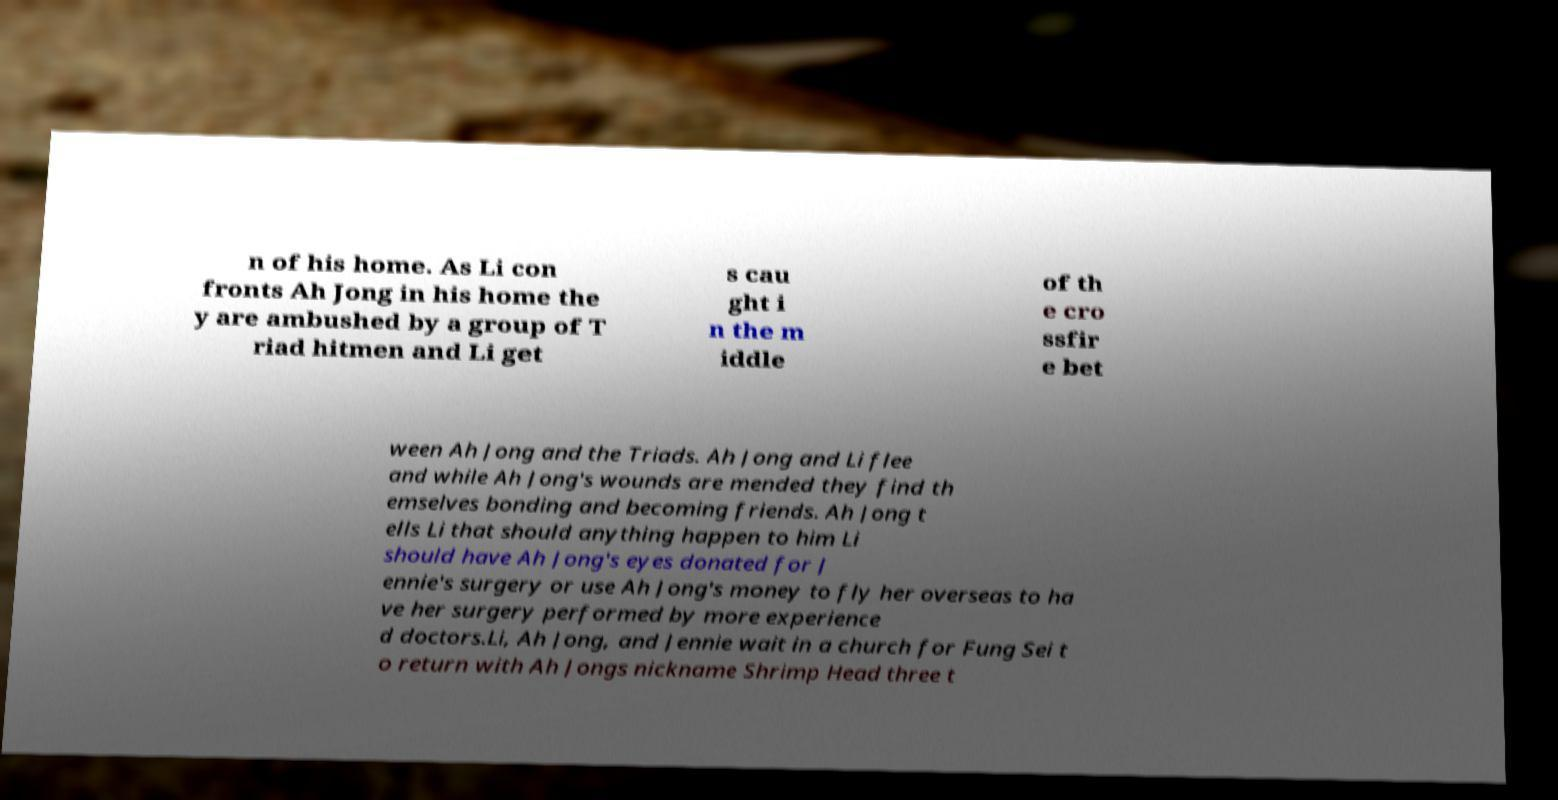For documentation purposes, I need the text within this image transcribed. Could you provide that? n of his home. As Li con fronts Ah Jong in his home the y are ambushed by a group of T riad hitmen and Li get s cau ght i n the m iddle of th e cro ssfir e bet ween Ah Jong and the Triads. Ah Jong and Li flee and while Ah Jong's wounds are mended they find th emselves bonding and becoming friends. Ah Jong t ells Li that should anything happen to him Li should have Ah Jong's eyes donated for J ennie's surgery or use Ah Jong's money to fly her overseas to ha ve her surgery performed by more experience d doctors.Li, Ah Jong, and Jennie wait in a church for Fung Sei t o return with Ah Jongs nickname Shrimp Head three t 